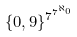<formula> <loc_0><loc_0><loc_500><loc_500>\{ 0 , 9 \} ^ { 7 ^ { 7 ^ { \aleph _ { 0 } } } }</formula> 